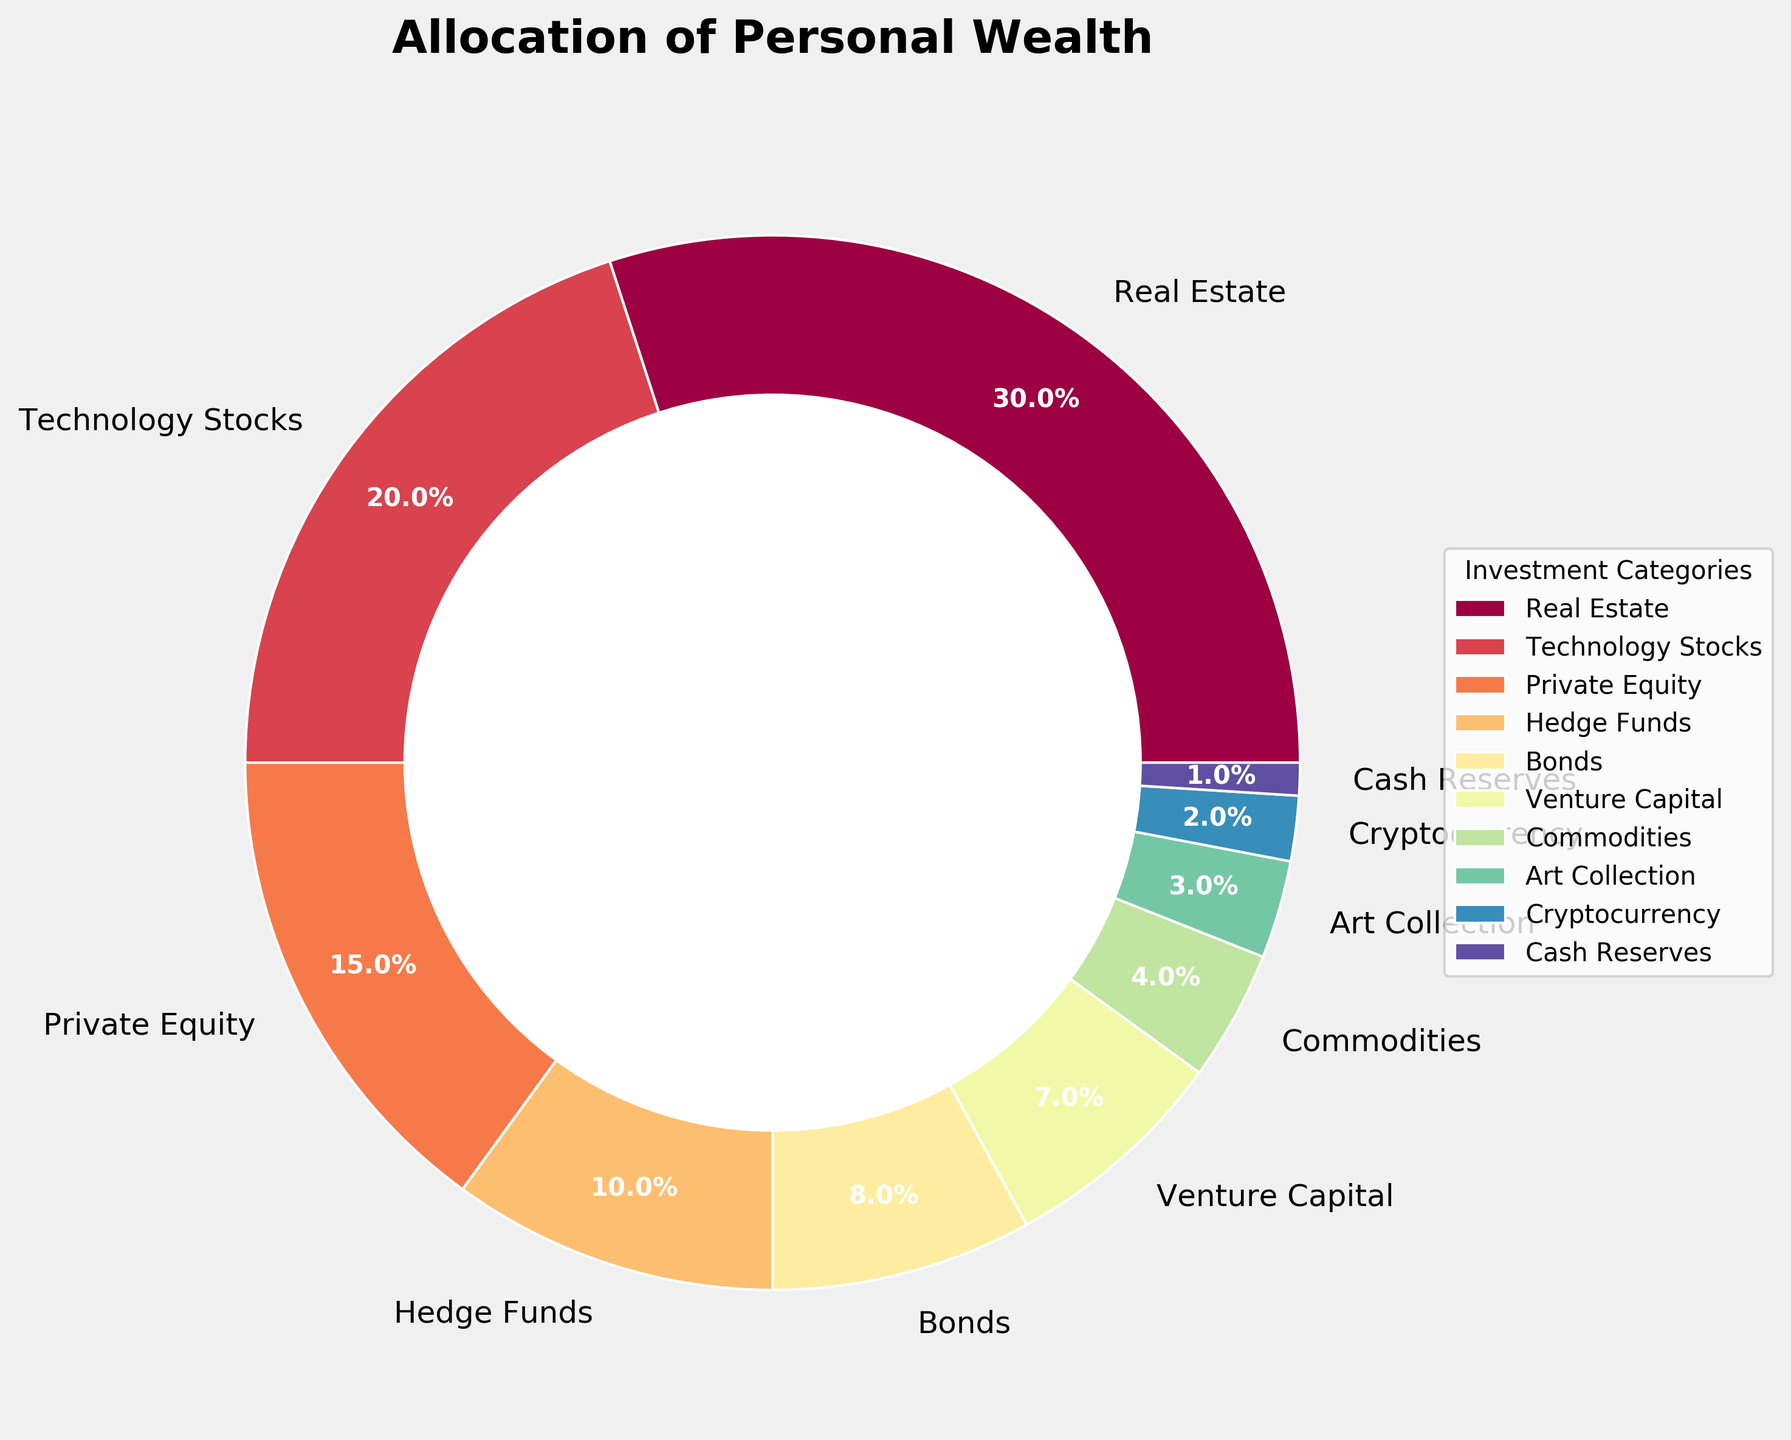What is the largest investment category? By looking at the size of the slices, the "Real Estate" slice is the largest in the pie chart. Additionally, the label shows 30%, which is the highest percentage among all categories.
Answer: Real Estate What is the combined percentage of investment in Bonds, Commodities, and Cryptocurrency? The percentages for Bonds, Commodities, and Cryptocurrency are 8%, 4%, and 2%, respectively. Adding them together gives 8 + 4 + 2 = 14%.
Answer: 14% Which investment category is allocated exactly half of the percentage of the largest category? The largest category is "Real Estate" at 30%. Half of 30% is 15%. Therefore, "Private Equity" is allocated 15%, which is exactly half of the largest category.
Answer: Private Equity How does the percentage of investment in Cash Reserves compare to that in Venture Capital? The percentage allocated to Cash Reserves is 1%, whereas Venture Capital is allocated 7%. Therefore, the investment in Venture Capital is greater than in Cash Reserves.
Answer: Venture Capital > Cash Reserves Which investment categories have allocations less than 5%? The categories with allocations less than 5% are Commodities (4%), Art Collection (3%), Cryptocurrency (2%), and Cash Reserves (1%).
Answer: Commodities, Art Collection, Cryptocurrency, Cash Reserves What is the total percentage allocated to technology-related investments? The technology-related investments in the figure are Technology Stocks (20%) and Venture Capital (7%). Adding them together gives 20 + 7 = 27%.
Answer: 27% How does the percentage of investment in Hedge Funds compare to that in Private Equity? Hedge Funds have a 10% allocation, while Private Equity has 15%. Therefore, the percentage allocated to Private Equity is greater than that for Hedge Funds.
Answer: Private Equity > Hedge Funds What is the smallest investment category? By looking at the size of the slices and the labels, the smallest investment category is Cash Reserves with 1%.
Answer: Cash Reserves What is the combined percentage of the two largest investment categories? The two largest investment categories are Real Estate (30%) and Technology Stocks (20%). Adding them together gives 30 + 20 = 50%.
Answer: 50% What is the difference in percentage between the highest and lowest investment categories? The highest investment category is Real Estate at 30%, and the lowest is Cash Reserves at 1%. The difference between them is 30 - 1 = 29%.
Answer: 29% 